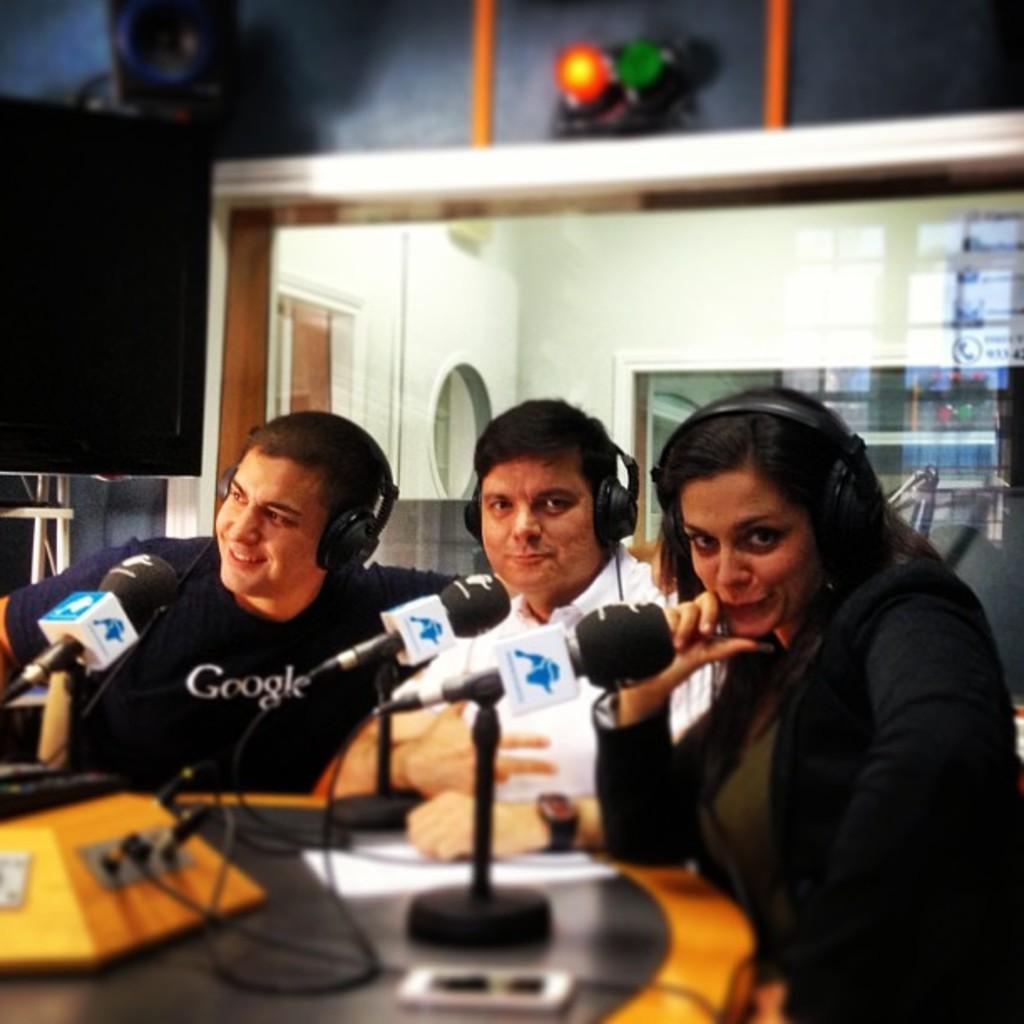Can you describe this image briefly? In the image we can see there are people who are sitting on chair and they are wearing headphones and in front of them there is a mic on the table. 